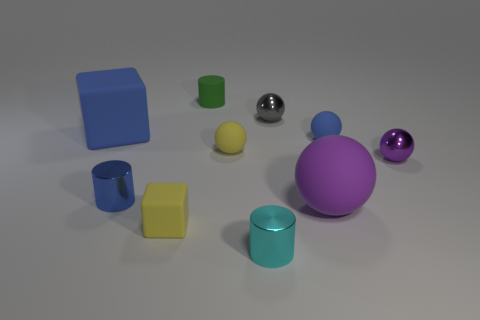There is a tiny cylinder that is to the left of the matte block that is in front of the large sphere; how many tiny green cylinders are in front of it?
Ensure brevity in your answer.  0. There is a large ball; is it the same color as the tiny metal sphere that is right of the blue matte ball?
Ensure brevity in your answer.  Yes. The thing that is the same color as the tiny matte cube is what shape?
Ensure brevity in your answer.  Sphere. What material is the tiny ball in front of the matte ball left of the tiny shiny thing behind the large blue object?
Your response must be concise. Metal. There is a tiny yellow thing that is in front of the big purple ball; is it the same shape as the purple shiny object?
Offer a terse response. No. There is a cylinder that is in front of the small blue shiny cylinder; what is its material?
Ensure brevity in your answer.  Metal. What number of matte things are either large cubes or yellow things?
Ensure brevity in your answer.  3. Are there any rubber cylinders that have the same size as the cyan metal cylinder?
Provide a short and direct response. Yes. Are there more matte objects that are in front of the small green rubber object than cyan spheres?
Make the answer very short. Yes. What number of small objects are purple cubes or purple matte spheres?
Offer a very short reply. 0. 